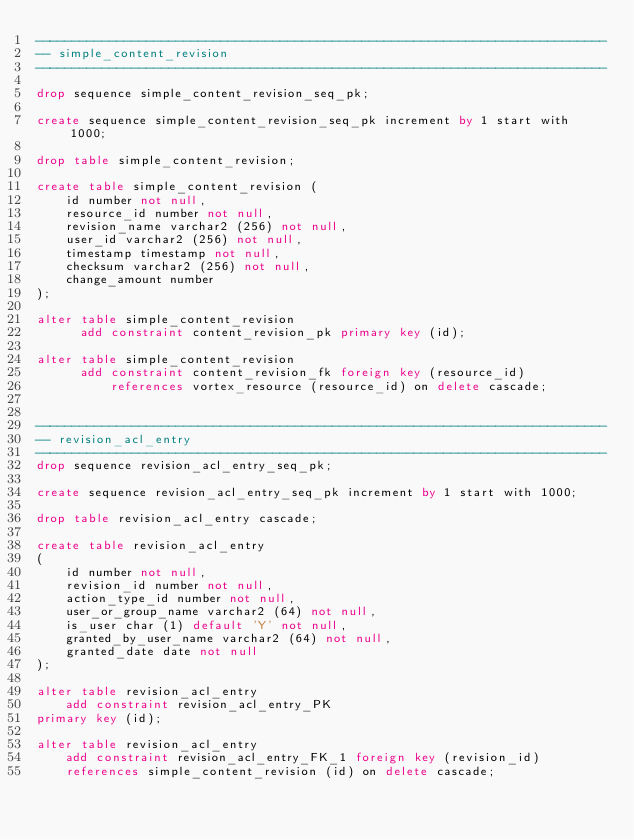Convert code to text. <code><loc_0><loc_0><loc_500><loc_500><_SQL_>-----------------------------------------------------------------------------
-- simple_content_revision
-----------------------------------------------------------------------------

drop sequence simple_content_revision_seq_pk;

create sequence simple_content_revision_seq_pk increment by 1 start with 1000;

drop table simple_content_revision;

create table simple_content_revision (
    id number not null,
    resource_id number not null,
    revision_name varchar2 (256) not null,
    user_id varchar2 (256) not null,
    timestamp timestamp not null,
    checksum varchar2 (256) not null,
    change_amount number
);

alter table simple_content_revision
      add constraint content_revision_pk primary key (id);

alter table simple_content_revision
      add constraint content_revision_fk foreign key (resource_id)
          references vortex_resource (resource_id) on delete cascade;


-----------------------------------------------------------------------------
-- revision_acl_entry
-----------------------------------------------------------------------------
drop sequence revision_acl_entry_seq_pk;

create sequence revision_acl_entry_seq_pk increment by 1 start with 1000;

drop table revision_acl_entry cascade;

create table revision_acl_entry
(
    id number not null,
    revision_id number not null,
    action_type_id number not null,
    user_or_group_name varchar2 (64) not null,
    is_user char (1) default 'Y' not null,
    granted_by_user_name varchar2 (64) not null,
    granted_date date not null
);

alter table revision_acl_entry
    add constraint revision_acl_entry_PK
primary key (id);

alter table revision_acl_entry
    add constraint revision_acl_entry_FK_1 foreign key (revision_id)
    references simple_content_revision (id) on delete cascade;
</code> 